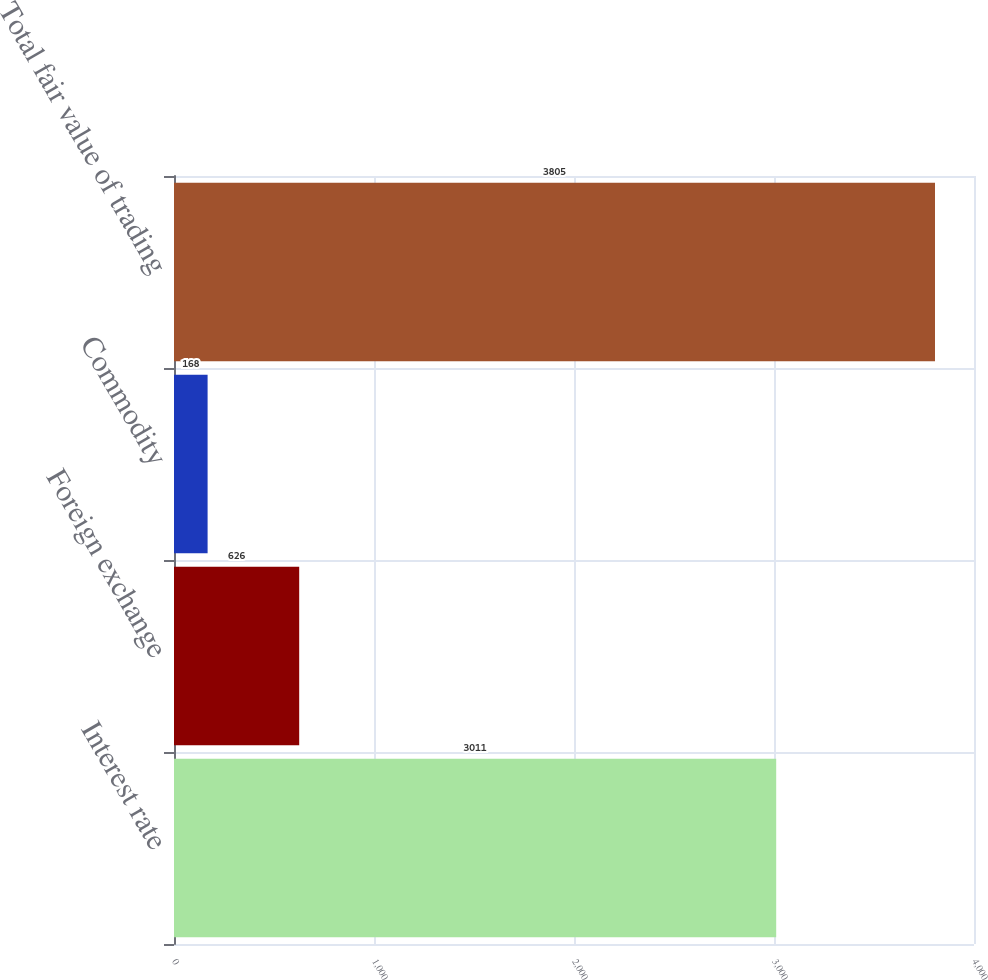<chart> <loc_0><loc_0><loc_500><loc_500><bar_chart><fcel>Interest rate<fcel>Foreign exchange<fcel>Commodity<fcel>Total fair value of trading<nl><fcel>3011<fcel>626<fcel>168<fcel>3805<nl></chart> 